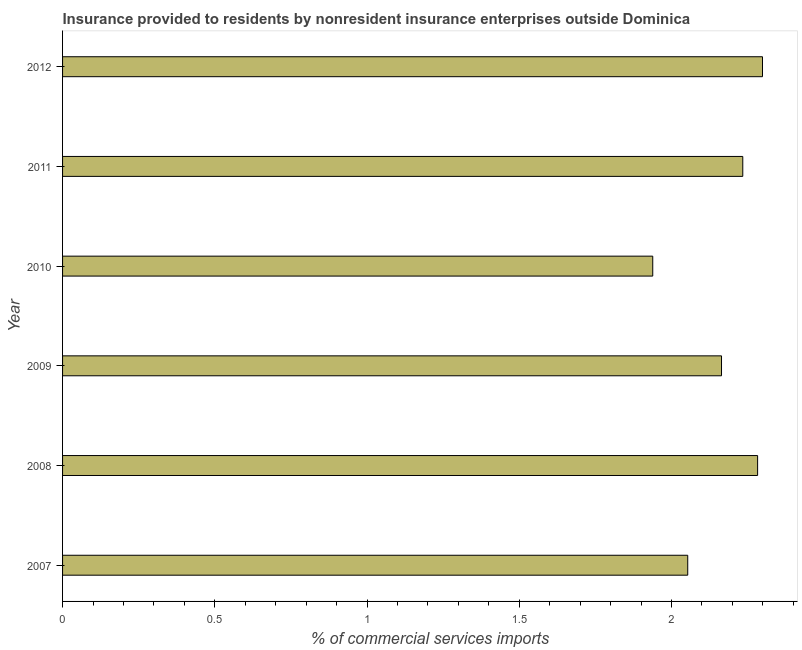Does the graph contain any zero values?
Your response must be concise. No. Does the graph contain grids?
Offer a very short reply. No. What is the title of the graph?
Ensure brevity in your answer.  Insurance provided to residents by nonresident insurance enterprises outside Dominica. What is the label or title of the X-axis?
Your response must be concise. % of commercial services imports. What is the insurance provided by non-residents in 2011?
Ensure brevity in your answer.  2.23. Across all years, what is the maximum insurance provided by non-residents?
Provide a short and direct response. 2.3. Across all years, what is the minimum insurance provided by non-residents?
Provide a short and direct response. 1.94. In which year was the insurance provided by non-residents maximum?
Make the answer very short. 2012. What is the sum of the insurance provided by non-residents?
Your answer should be very brief. 12.97. What is the difference between the insurance provided by non-residents in 2008 and 2011?
Offer a very short reply. 0.05. What is the average insurance provided by non-residents per year?
Your response must be concise. 2.16. What is the median insurance provided by non-residents?
Your response must be concise. 2.2. In how many years, is the insurance provided by non-residents greater than 1.4 %?
Offer a very short reply. 6. Do a majority of the years between 2009 and 2012 (inclusive) have insurance provided by non-residents greater than 1.8 %?
Give a very brief answer. Yes. Is the insurance provided by non-residents in 2011 less than that in 2012?
Make the answer very short. Yes. What is the difference between the highest and the second highest insurance provided by non-residents?
Provide a short and direct response. 0.02. Is the sum of the insurance provided by non-residents in 2011 and 2012 greater than the maximum insurance provided by non-residents across all years?
Make the answer very short. Yes. What is the difference between the highest and the lowest insurance provided by non-residents?
Keep it short and to the point. 0.36. In how many years, is the insurance provided by non-residents greater than the average insurance provided by non-residents taken over all years?
Give a very brief answer. 4. How many bars are there?
Your answer should be very brief. 6. Are all the bars in the graph horizontal?
Offer a terse response. Yes. Are the values on the major ticks of X-axis written in scientific E-notation?
Keep it short and to the point. No. What is the % of commercial services imports in 2007?
Offer a terse response. 2.05. What is the % of commercial services imports in 2008?
Your answer should be very brief. 2.28. What is the % of commercial services imports of 2009?
Your response must be concise. 2.16. What is the % of commercial services imports in 2010?
Provide a succinct answer. 1.94. What is the % of commercial services imports in 2011?
Offer a terse response. 2.23. What is the % of commercial services imports in 2012?
Provide a succinct answer. 2.3. What is the difference between the % of commercial services imports in 2007 and 2008?
Make the answer very short. -0.23. What is the difference between the % of commercial services imports in 2007 and 2009?
Offer a terse response. -0.11. What is the difference between the % of commercial services imports in 2007 and 2010?
Provide a short and direct response. 0.11. What is the difference between the % of commercial services imports in 2007 and 2011?
Provide a short and direct response. -0.18. What is the difference between the % of commercial services imports in 2007 and 2012?
Keep it short and to the point. -0.25. What is the difference between the % of commercial services imports in 2008 and 2009?
Offer a terse response. 0.12. What is the difference between the % of commercial services imports in 2008 and 2010?
Your response must be concise. 0.34. What is the difference between the % of commercial services imports in 2008 and 2011?
Provide a succinct answer. 0.05. What is the difference between the % of commercial services imports in 2008 and 2012?
Offer a very short reply. -0.02. What is the difference between the % of commercial services imports in 2009 and 2010?
Provide a succinct answer. 0.23. What is the difference between the % of commercial services imports in 2009 and 2011?
Keep it short and to the point. -0.07. What is the difference between the % of commercial services imports in 2009 and 2012?
Your response must be concise. -0.13. What is the difference between the % of commercial services imports in 2010 and 2011?
Offer a very short reply. -0.3. What is the difference between the % of commercial services imports in 2010 and 2012?
Your answer should be very brief. -0.36. What is the difference between the % of commercial services imports in 2011 and 2012?
Ensure brevity in your answer.  -0.06. What is the ratio of the % of commercial services imports in 2007 to that in 2008?
Provide a short and direct response. 0.9. What is the ratio of the % of commercial services imports in 2007 to that in 2009?
Make the answer very short. 0.95. What is the ratio of the % of commercial services imports in 2007 to that in 2010?
Offer a very short reply. 1.06. What is the ratio of the % of commercial services imports in 2007 to that in 2011?
Make the answer very short. 0.92. What is the ratio of the % of commercial services imports in 2007 to that in 2012?
Ensure brevity in your answer.  0.89. What is the ratio of the % of commercial services imports in 2008 to that in 2009?
Give a very brief answer. 1.05. What is the ratio of the % of commercial services imports in 2008 to that in 2010?
Keep it short and to the point. 1.18. What is the ratio of the % of commercial services imports in 2008 to that in 2011?
Your answer should be very brief. 1.02. What is the ratio of the % of commercial services imports in 2009 to that in 2010?
Offer a terse response. 1.12. What is the ratio of the % of commercial services imports in 2009 to that in 2011?
Offer a terse response. 0.97. What is the ratio of the % of commercial services imports in 2009 to that in 2012?
Your answer should be very brief. 0.94. What is the ratio of the % of commercial services imports in 2010 to that in 2011?
Provide a succinct answer. 0.87. What is the ratio of the % of commercial services imports in 2010 to that in 2012?
Offer a very short reply. 0.84. 